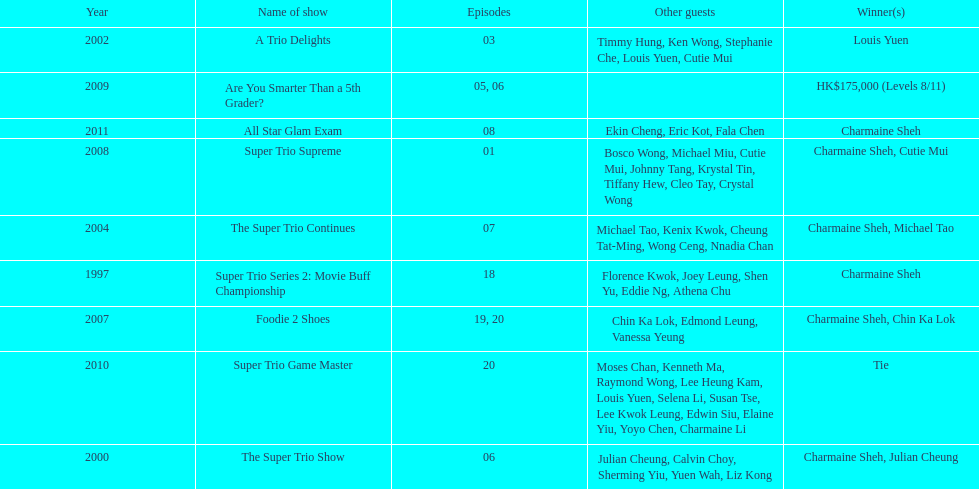What was the total number of trio series shows were charmaine sheh on? 6. 